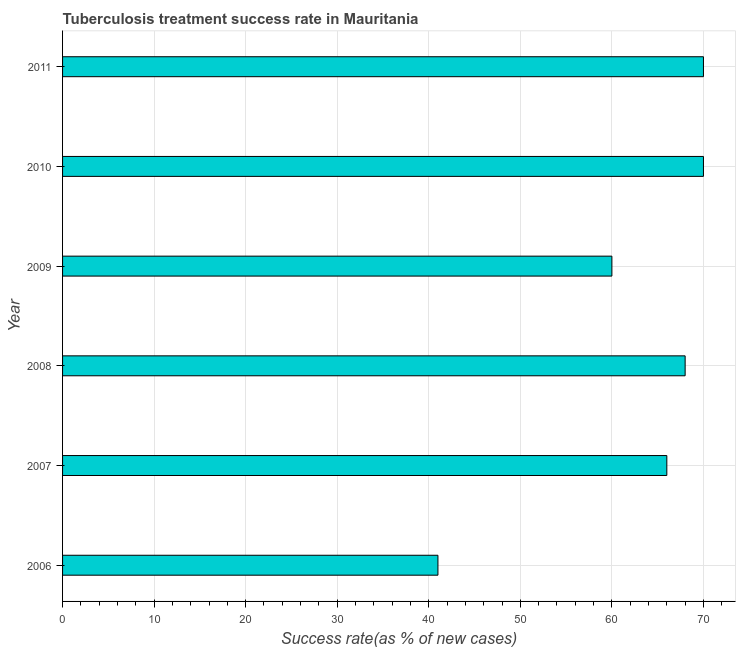Does the graph contain any zero values?
Offer a very short reply. No. What is the title of the graph?
Keep it short and to the point. Tuberculosis treatment success rate in Mauritania. What is the label or title of the X-axis?
Make the answer very short. Success rate(as % of new cases). What is the label or title of the Y-axis?
Provide a succinct answer. Year. What is the tuberculosis treatment success rate in 2007?
Keep it short and to the point. 66. In which year was the tuberculosis treatment success rate minimum?
Your answer should be very brief. 2006. What is the sum of the tuberculosis treatment success rate?
Provide a succinct answer. 375. What is the median tuberculosis treatment success rate?
Your response must be concise. 67. Do a majority of the years between 2008 and 2006 (inclusive) have tuberculosis treatment success rate greater than 8 %?
Keep it short and to the point. Yes. What is the ratio of the tuberculosis treatment success rate in 2008 to that in 2009?
Give a very brief answer. 1.13. Is the tuberculosis treatment success rate in 2010 less than that in 2011?
Keep it short and to the point. No. What is the difference between the highest and the second highest tuberculosis treatment success rate?
Keep it short and to the point. 0. Is the sum of the tuberculosis treatment success rate in 2007 and 2010 greater than the maximum tuberculosis treatment success rate across all years?
Make the answer very short. Yes. In how many years, is the tuberculosis treatment success rate greater than the average tuberculosis treatment success rate taken over all years?
Keep it short and to the point. 4. What is the Success rate(as % of new cases) in 2007?
Your response must be concise. 66. What is the Success rate(as % of new cases) of 2009?
Keep it short and to the point. 60. What is the difference between the Success rate(as % of new cases) in 2006 and 2007?
Ensure brevity in your answer.  -25. What is the difference between the Success rate(as % of new cases) in 2006 and 2008?
Make the answer very short. -27. What is the difference between the Success rate(as % of new cases) in 2006 and 2009?
Give a very brief answer. -19. What is the difference between the Success rate(as % of new cases) in 2006 and 2010?
Your answer should be compact. -29. What is the difference between the Success rate(as % of new cases) in 2007 and 2009?
Your answer should be very brief. 6. What is the difference between the Success rate(as % of new cases) in 2007 and 2010?
Offer a very short reply. -4. What is the difference between the Success rate(as % of new cases) in 2008 and 2009?
Your answer should be compact. 8. What is the difference between the Success rate(as % of new cases) in 2009 and 2011?
Offer a very short reply. -10. What is the difference between the Success rate(as % of new cases) in 2010 and 2011?
Your answer should be compact. 0. What is the ratio of the Success rate(as % of new cases) in 2006 to that in 2007?
Ensure brevity in your answer.  0.62. What is the ratio of the Success rate(as % of new cases) in 2006 to that in 2008?
Give a very brief answer. 0.6. What is the ratio of the Success rate(as % of new cases) in 2006 to that in 2009?
Provide a short and direct response. 0.68. What is the ratio of the Success rate(as % of new cases) in 2006 to that in 2010?
Ensure brevity in your answer.  0.59. What is the ratio of the Success rate(as % of new cases) in 2006 to that in 2011?
Make the answer very short. 0.59. What is the ratio of the Success rate(as % of new cases) in 2007 to that in 2008?
Your response must be concise. 0.97. What is the ratio of the Success rate(as % of new cases) in 2007 to that in 2010?
Ensure brevity in your answer.  0.94. What is the ratio of the Success rate(as % of new cases) in 2007 to that in 2011?
Your response must be concise. 0.94. What is the ratio of the Success rate(as % of new cases) in 2008 to that in 2009?
Your answer should be compact. 1.13. What is the ratio of the Success rate(as % of new cases) in 2009 to that in 2010?
Make the answer very short. 0.86. What is the ratio of the Success rate(as % of new cases) in 2009 to that in 2011?
Your answer should be very brief. 0.86. What is the ratio of the Success rate(as % of new cases) in 2010 to that in 2011?
Offer a very short reply. 1. 